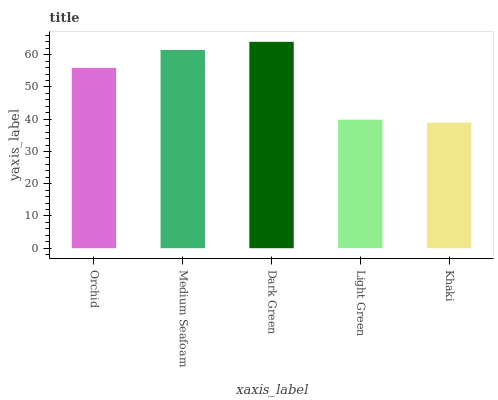Is Medium Seafoam the minimum?
Answer yes or no. No. Is Medium Seafoam the maximum?
Answer yes or no. No. Is Medium Seafoam greater than Orchid?
Answer yes or no. Yes. Is Orchid less than Medium Seafoam?
Answer yes or no. Yes. Is Orchid greater than Medium Seafoam?
Answer yes or no. No. Is Medium Seafoam less than Orchid?
Answer yes or no. No. Is Orchid the high median?
Answer yes or no. Yes. Is Orchid the low median?
Answer yes or no. Yes. Is Medium Seafoam the high median?
Answer yes or no. No. Is Light Green the low median?
Answer yes or no. No. 